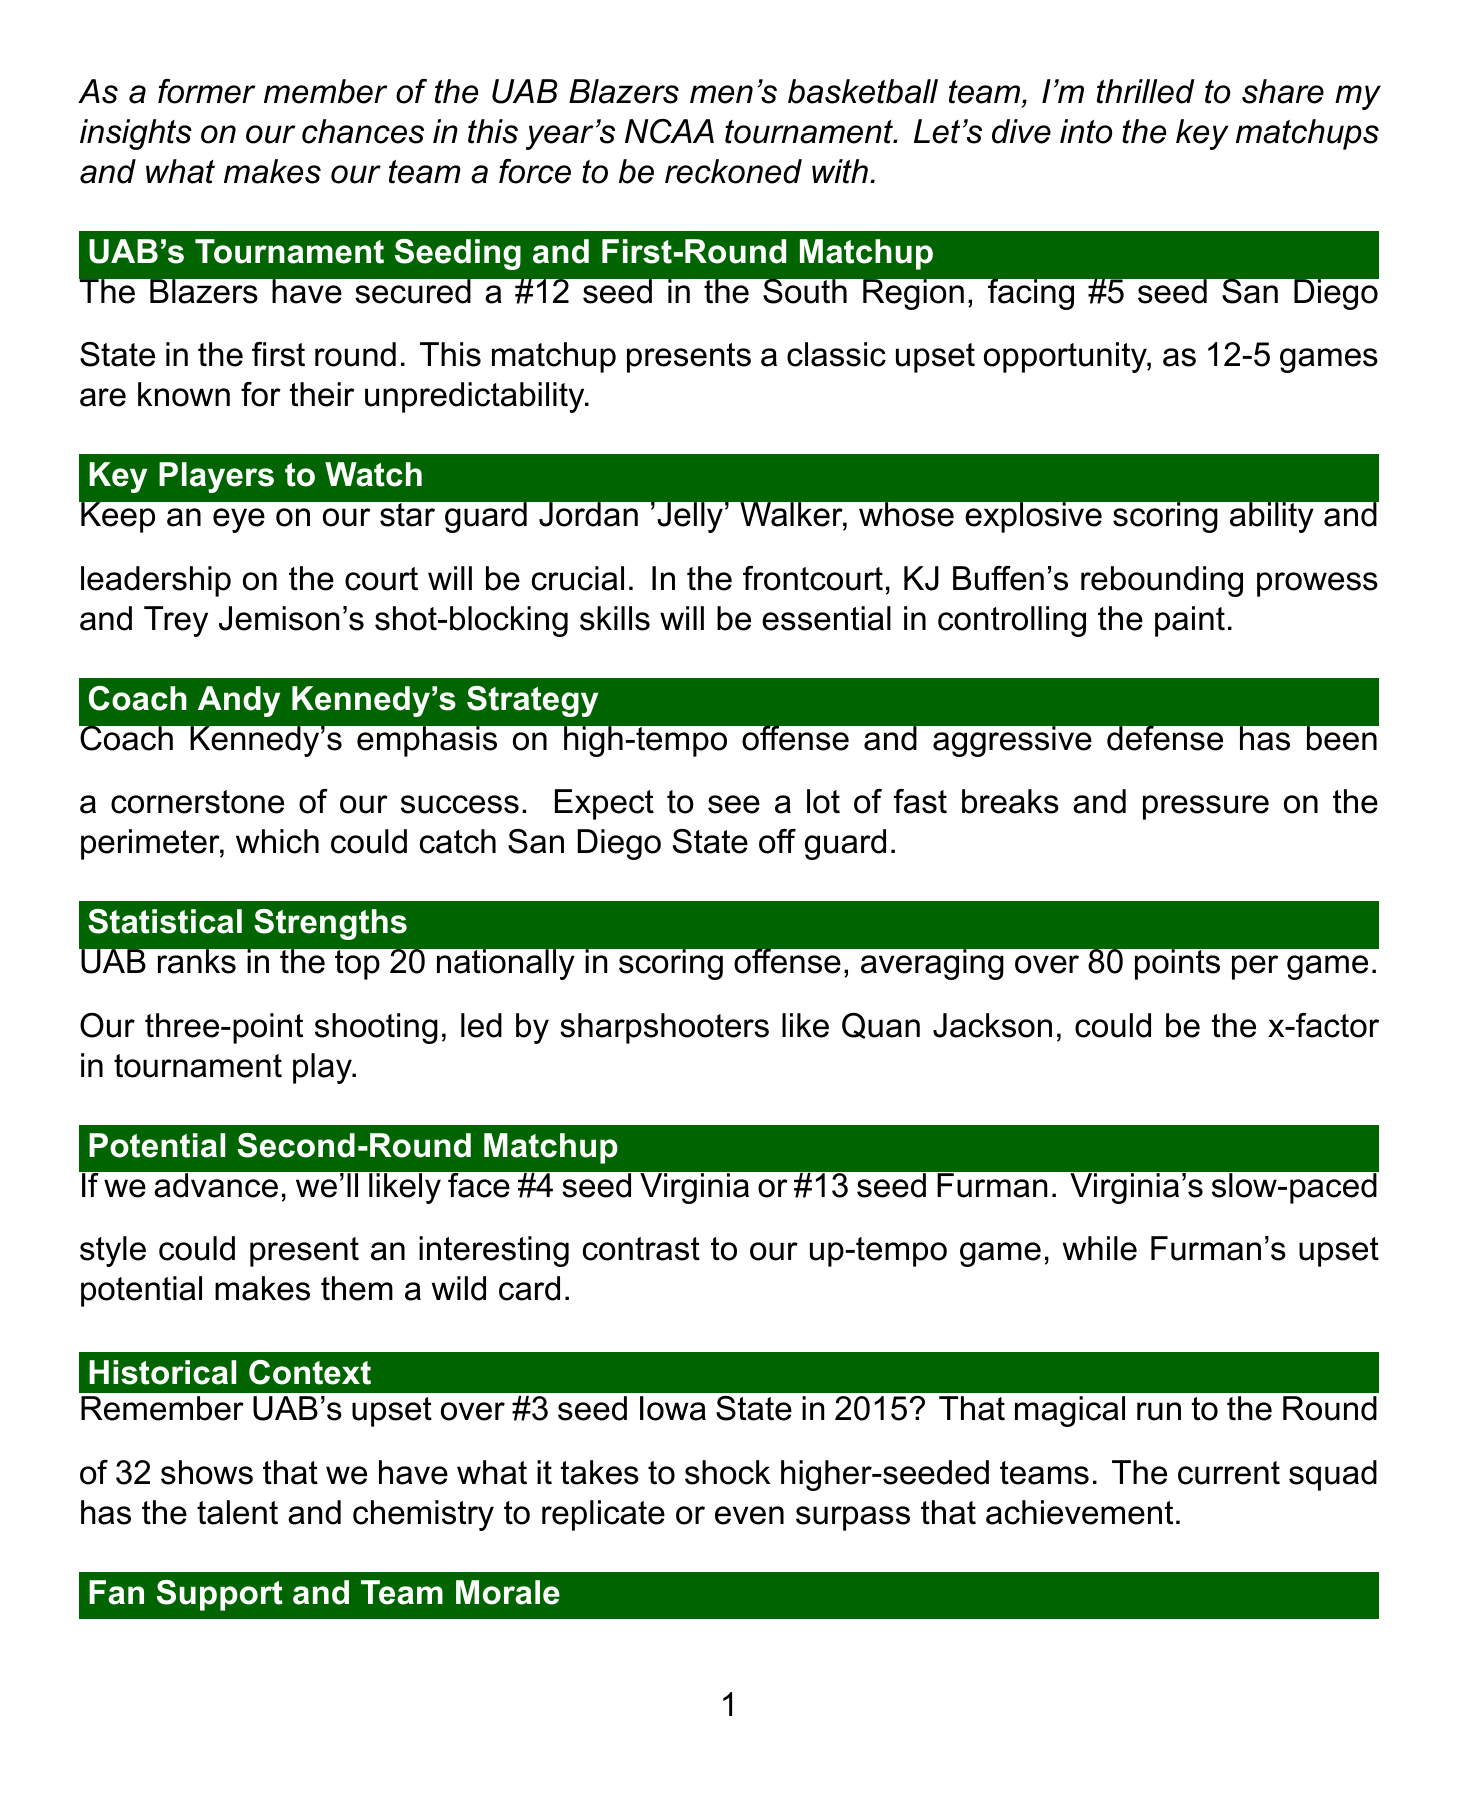What seed is UAB in the tournament? UAB has secured a #12 seed in the South Region as mentioned in the document.
Answer: #12 Who is UAB's star guard? The document highlights Jordan 'Jelly' Walker as UAB's star guard.
Answer: Jordan 'Jelly' Walker What is Coach Andy Kennedy's strategy? The document states that Coach Kennedy emphasizes high-tempo offense and aggressive defense.
Answer: High-tempo offense and aggressive defense What is UAB's average points per game? The newsletter mentions UAB ranks in the top 20 nationally, averaging over 80 points per game.
Answer: Over 80 points What team might UAB face in the second round? According to the document, UAB might face #4 seed Virginia or #13 seed Furman in the second round.
Answer: #4 seed Virginia or #13 seed Furman What significant upset is referenced from 2015? The document recalls UAB's upset over #3 seed Iowa State in 2015 as a historical context.
Answer: Upset over #3 seed Iowa State What venue did UAB have strong fan support? The document refers to the energy at Bartow Arena during the Conference USA championship run.
Answer: Bartow Arena What is one of the keys to UAB's success mentioned? The newsletter lists maintaining a high-scoring offense against tougher defenses as a key to success.
Answer: Maintain high-scoring offense What color represents UAB in the newsletter title? The document's title uses the color associated with UAB, which is green.
Answer: Green 